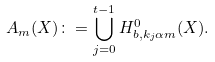<formula> <loc_0><loc_0><loc_500><loc_500>A _ { m } ( X ) \colon = \bigcup ^ { t - 1 } _ { j = 0 } H ^ { 0 } _ { b , k _ { j } \alpha m } ( X ) .</formula> 